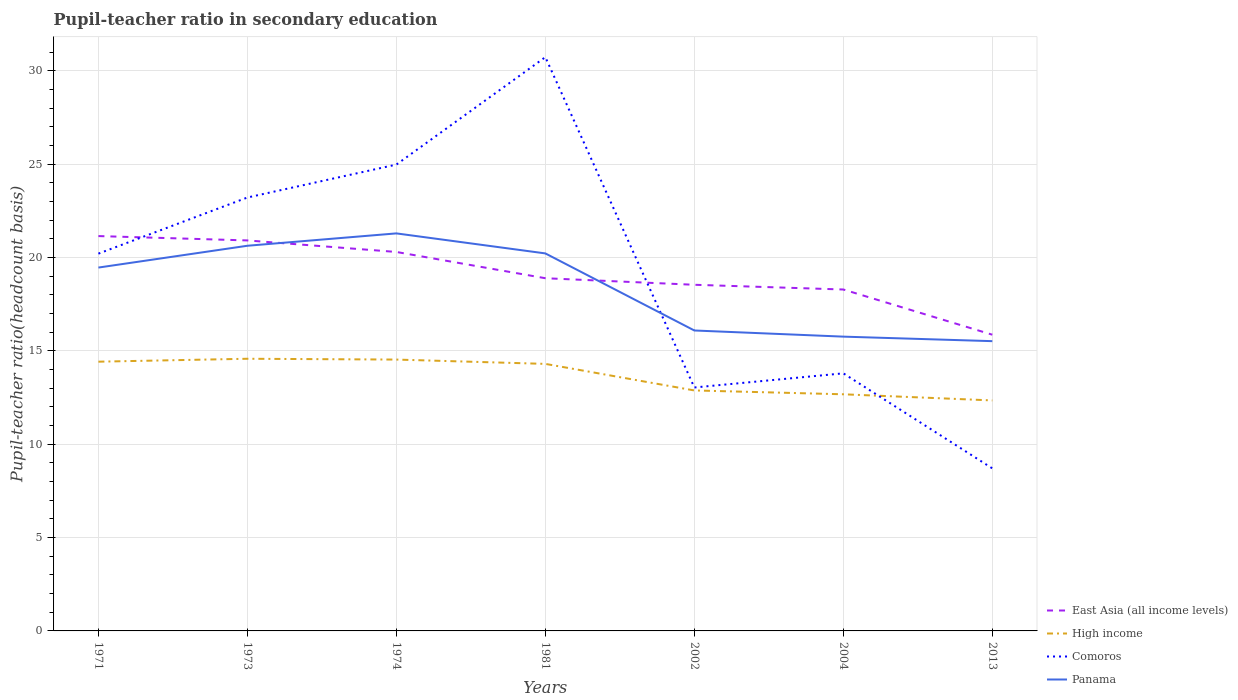How many different coloured lines are there?
Give a very brief answer. 4. Does the line corresponding to East Asia (all income levels) intersect with the line corresponding to Panama?
Make the answer very short. Yes. Across all years, what is the maximum pupil-teacher ratio in secondary education in High income?
Make the answer very short. 12.34. What is the total pupil-teacher ratio in secondary education in High income in the graph?
Offer a very short reply. 1.63. What is the difference between the highest and the second highest pupil-teacher ratio in secondary education in High income?
Provide a succinct answer. 2.23. What is the difference between the highest and the lowest pupil-teacher ratio in secondary education in High income?
Offer a very short reply. 4. What is the difference between two consecutive major ticks on the Y-axis?
Keep it short and to the point. 5. Are the values on the major ticks of Y-axis written in scientific E-notation?
Keep it short and to the point. No. Does the graph contain any zero values?
Offer a very short reply. No. Does the graph contain grids?
Your response must be concise. Yes. How many legend labels are there?
Provide a short and direct response. 4. What is the title of the graph?
Offer a terse response. Pupil-teacher ratio in secondary education. Does "Thailand" appear as one of the legend labels in the graph?
Provide a succinct answer. No. What is the label or title of the X-axis?
Your response must be concise. Years. What is the label or title of the Y-axis?
Keep it short and to the point. Pupil-teacher ratio(headcount basis). What is the Pupil-teacher ratio(headcount basis) of East Asia (all income levels) in 1971?
Offer a terse response. 21.15. What is the Pupil-teacher ratio(headcount basis) in High income in 1971?
Make the answer very short. 14.42. What is the Pupil-teacher ratio(headcount basis) of Comoros in 1971?
Your answer should be compact. 20.21. What is the Pupil-teacher ratio(headcount basis) in Panama in 1971?
Provide a succinct answer. 19.46. What is the Pupil-teacher ratio(headcount basis) of East Asia (all income levels) in 1973?
Ensure brevity in your answer.  20.91. What is the Pupil-teacher ratio(headcount basis) of High income in 1973?
Offer a very short reply. 14.58. What is the Pupil-teacher ratio(headcount basis) in Comoros in 1973?
Give a very brief answer. 23.21. What is the Pupil-teacher ratio(headcount basis) of Panama in 1973?
Your response must be concise. 20.63. What is the Pupil-teacher ratio(headcount basis) in East Asia (all income levels) in 1974?
Ensure brevity in your answer.  20.3. What is the Pupil-teacher ratio(headcount basis) of High income in 1974?
Your answer should be compact. 14.53. What is the Pupil-teacher ratio(headcount basis) in Comoros in 1974?
Offer a terse response. 24.98. What is the Pupil-teacher ratio(headcount basis) in Panama in 1974?
Your response must be concise. 21.29. What is the Pupil-teacher ratio(headcount basis) in East Asia (all income levels) in 1981?
Your response must be concise. 18.89. What is the Pupil-teacher ratio(headcount basis) in High income in 1981?
Keep it short and to the point. 14.3. What is the Pupil-teacher ratio(headcount basis) of Comoros in 1981?
Offer a very short reply. 30.73. What is the Pupil-teacher ratio(headcount basis) in Panama in 1981?
Provide a succinct answer. 20.22. What is the Pupil-teacher ratio(headcount basis) in East Asia (all income levels) in 2002?
Provide a succinct answer. 18.54. What is the Pupil-teacher ratio(headcount basis) of High income in 2002?
Give a very brief answer. 12.88. What is the Pupil-teacher ratio(headcount basis) in Comoros in 2002?
Provide a short and direct response. 13.04. What is the Pupil-teacher ratio(headcount basis) of Panama in 2002?
Your answer should be very brief. 16.09. What is the Pupil-teacher ratio(headcount basis) in East Asia (all income levels) in 2004?
Keep it short and to the point. 18.29. What is the Pupil-teacher ratio(headcount basis) of High income in 2004?
Keep it short and to the point. 12.67. What is the Pupil-teacher ratio(headcount basis) of Comoros in 2004?
Provide a short and direct response. 13.8. What is the Pupil-teacher ratio(headcount basis) of Panama in 2004?
Keep it short and to the point. 15.76. What is the Pupil-teacher ratio(headcount basis) of East Asia (all income levels) in 2013?
Keep it short and to the point. 15.86. What is the Pupil-teacher ratio(headcount basis) of High income in 2013?
Provide a short and direct response. 12.34. What is the Pupil-teacher ratio(headcount basis) in Comoros in 2013?
Ensure brevity in your answer.  8.71. What is the Pupil-teacher ratio(headcount basis) of Panama in 2013?
Make the answer very short. 15.52. Across all years, what is the maximum Pupil-teacher ratio(headcount basis) in East Asia (all income levels)?
Keep it short and to the point. 21.15. Across all years, what is the maximum Pupil-teacher ratio(headcount basis) of High income?
Provide a short and direct response. 14.58. Across all years, what is the maximum Pupil-teacher ratio(headcount basis) of Comoros?
Your answer should be very brief. 30.73. Across all years, what is the maximum Pupil-teacher ratio(headcount basis) of Panama?
Ensure brevity in your answer.  21.29. Across all years, what is the minimum Pupil-teacher ratio(headcount basis) of East Asia (all income levels)?
Your answer should be compact. 15.86. Across all years, what is the minimum Pupil-teacher ratio(headcount basis) in High income?
Offer a very short reply. 12.34. Across all years, what is the minimum Pupil-teacher ratio(headcount basis) in Comoros?
Offer a very short reply. 8.71. Across all years, what is the minimum Pupil-teacher ratio(headcount basis) in Panama?
Your answer should be compact. 15.52. What is the total Pupil-teacher ratio(headcount basis) of East Asia (all income levels) in the graph?
Your answer should be very brief. 133.94. What is the total Pupil-teacher ratio(headcount basis) in High income in the graph?
Provide a short and direct response. 95.73. What is the total Pupil-teacher ratio(headcount basis) of Comoros in the graph?
Provide a short and direct response. 134.67. What is the total Pupil-teacher ratio(headcount basis) of Panama in the graph?
Provide a short and direct response. 128.97. What is the difference between the Pupil-teacher ratio(headcount basis) in East Asia (all income levels) in 1971 and that in 1973?
Your response must be concise. 0.23. What is the difference between the Pupil-teacher ratio(headcount basis) in High income in 1971 and that in 1973?
Provide a short and direct response. -0.16. What is the difference between the Pupil-teacher ratio(headcount basis) of Comoros in 1971 and that in 1973?
Your response must be concise. -3.01. What is the difference between the Pupil-teacher ratio(headcount basis) of Panama in 1971 and that in 1973?
Give a very brief answer. -1.17. What is the difference between the Pupil-teacher ratio(headcount basis) in East Asia (all income levels) in 1971 and that in 1974?
Keep it short and to the point. 0.85. What is the difference between the Pupil-teacher ratio(headcount basis) in High income in 1971 and that in 1974?
Make the answer very short. -0.11. What is the difference between the Pupil-teacher ratio(headcount basis) of Comoros in 1971 and that in 1974?
Keep it short and to the point. -4.77. What is the difference between the Pupil-teacher ratio(headcount basis) of Panama in 1971 and that in 1974?
Offer a terse response. -1.83. What is the difference between the Pupil-teacher ratio(headcount basis) of East Asia (all income levels) in 1971 and that in 1981?
Make the answer very short. 2.26. What is the difference between the Pupil-teacher ratio(headcount basis) in High income in 1971 and that in 1981?
Provide a short and direct response. 0.12. What is the difference between the Pupil-teacher ratio(headcount basis) in Comoros in 1971 and that in 1981?
Your answer should be compact. -10.52. What is the difference between the Pupil-teacher ratio(headcount basis) of Panama in 1971 and that in 1981?
Provide a short and direct response. -0.76. What is the difference between the Pupil-teacher ratio(headcount basis) in East Asia (all income levels) in 1971 and that in 2002?
Your answer should be compact. 2.61. What is the difference between the Pupil-teacher ratio(headcount basis) in High income in 1971 and that in 2002?
Your response must be concise. 1.54. What is the difference between the Pupil-teacher ratio(headcount basis) in Comoros in 1971 and that in 2002?
Your response must be concise. 7.17. What is the difference between the Pupil-teacher ratio(headcount basis) in Panama in 1971 and that in 2002?
Provide a short and direct response. 3.37. What is the difference between the Pupil-teacher ratio(headcount basis) of East Asia (all income levels) in 1971 and that in 2004?
Ensure brevity in your answer.  2.86. What is the difference between the Pupil-teacher ratio(headcount basis) in High income in 1971 and that in 2004?
Give a very brief answer. 1.75. What is the difference between the Pupil-teacher ratio(headcount basis) of Comoros in 1971 and that in 2004?
Offer a very short reply. 6.41. What is the difference between the Pupil-teacher ratio(headcount basis) in Panama in 1971 and that in 2004?
Ensure brevity in your answer.  3.7. What is the difference between the Pupil-teacher ratio(headcount basis) of East Asia (all income levels) in 1971 and that in 2013?
Give a very brief answer. 5.28. What is the difference between the Pupil-teacher ratio(headcount basis) of High income in 1971 and that in 2013?
Your answer should be very brief. 2.08. What is the difference between the Pupil-teacher ratio(headcount basis) of Comoros in 1971 and that in 2013?
Offer a terse response. 11.5. What is the difference between the Pupil-teacher ratio(headcount basis) in Panama in 1971 and that in 2013?
Your answer should be compact. 3.94. What is the difference between the Pupil-teacher ratio(headcount basis) of East Asia (all income levels) in 1973 and that in 1974?
Offer a very short reply. 0.62. What is the difference between the Pupil-teacher ratio(headcount basis) in High income in 1973 and that in 1974?
Keep it short and to the point. 0.04. What is the difference between the Pupil-teacher ratio(headcount basis) of Comoros in 1973 and that in 1974?
Offer a very short reply. -1.76. What is the difference between the Pupil-teacher ratio(headcount basis) of Panama in 1973 and that in 1974?
Give a very brief answer. -0.66. What is the difference between the Pupil-teacher ratio(headcount basis) of East Asia (all income levels) in 1973 and that in 1981?
Provide a short and direct response. 2.02. What is the difference between the Pupil-teacher ratio(headcount basis) in High income in 1973 and that in 1981?
Offer a terse response. 0.27. What is the difference between the Pupil-teacher ratio(headcount basis) in Comoros in 1973 and that in 1981?
Offer a terse response. -7.52. What is the difference between the Pupil-teacher ratio(headcount basis) of Panama in 1973 and that in 1981?
Offer a very short reply. 0.41. What is the difference between the Pupil-teacher ratio(headcount basis) of East Asia (all income levels) in 1973 and that in 2002?
Your answer should be very brief. 2.38. What is the difference between the Pupil-teacher ratio(headcount basis) in High income in 1973 and that in 2002?
Provide a short and direct response. 1.7. What is the difference between the Pupil-teacher ratio(headcount basis) of Comoros in 1973 and that in 2002?
Your response must be concise. 10.17. What is the difference between the Pupil-teacher ratio(headcount basis) of Panama in 1973 and that in 2002?
Offer a very short reply. 4.54. What is the difference between the Pupil-teacher ratio(headcount basis) of East Asia (all income levels) in 1973 and that in 2004?
Give a very brief answer. 2.63. What is the difference between the Pupil-teacher ratio(headcount basis) in High income in 1973 and that in 2004?
Provide a succinct answer. 1.9. What is the difference between the Pupil-teacher ratio(headcount basis) of Comoros in 1973 and that in 2004?
Offer a very short reply. 9.42. What is the difference between the Pupil-teacher ratio(headcount basis) in Panama in 1973 and that in 2004?
Offer a very short reply. 4.87. What is the difference between the Pupil-teacher ratio(headcount basis) in East Asia (all income levels) in 1973 and that in 2013?
Keep it short and to the point. 5.05. What is the difference between the Pupil-teacher ratio(headcount basis) of High income in 1973 and that in 2013?
Give a very brief answer. 2.23. What is the difference between the Pupil-teacher ratio(headcount basis) in Comoros in 1973 and that in 2013?
Provide a succinct answer. 14.51. What is the difference between the Pupil-teacher ratio(headcount basis) in Panama in 1973 and that in 2013?
Offer a terse response. 5.11. What is the difference between the Pupil-teacher ratio(headcount basis) in East Asia (all income levels) in 1974 and that in 1981?
Offer a very short reply. 1.41. What is the difference between the Pupil-teacher ratio(headcount basis) in High income in 1974 and that in 1981?
Offer a terse response. 0.23. What is the difference between the Pupil-teacher ratio(headcount basis) of Comoros in 1974 and that in 1981?
Give a very brief answer. -5.75. What is the difference between the Pupil-teacher ratio(headcount basis) of Panama in 1974 and that in 1981?
Provide a short and direct response. 1.07. What is the difference between the Pupil-teacher ratio(headcount basis) of East Asia (all income levels) in 1974 and that in 2002?
Your answer should be very brief. 1.76. What is the difference between the Pupil-teacher ratio(headcount basis) of High income in 1974 and that in 2002?
Provide a succinct answer. 1.65. What is the difference between the Pupil-teacher ratio(headcount basis) of Comoros in 1974 and that in 2002?
Provide a succinct answer. 11.94. What is the difference between the Pupil-teacher ratio(headcount basis) of Panama in 1974 and that in 2002?
Offer a terse response. 5.2. What is the difference between the Pupil-teacher ratio(headcount basis) in East Asia (all income levels) in 1974 and that in 2004?
Offer a very short reply. 2.01. What is the difference between the Pupil-teacher ratio(headcount basis) of High income in 1974 and that in 2004?
Ensure brevity in your answer.  1.86. What is the difference between the Pupil-teacher ratio(headcount basis) in Comoros in 1974 and that in 2004?
Make the answer very short. 11.18. What is the difference between the Pupil-teacher ratio(headcount basis) of Panama in 1974 and that in 2004?
Offer a very short reply. 5.53. What is the difference between the Pupil-teacher ratio(headcount basis) of East Asia (all income levels) in 1974 and that in 2013?
Your response must be concise. 4.43. What is the difference between the Pupil-teacher ratio(headcount basis) of High income in 1974 and that in 2013?
Give a very brief answer. 2.19. What is the difference between the Pupil-teacher ratio(headcount basis) of Comoros in 1974 and that in 2013?
Provide a short and direct response. 16.27. What is the difference between the Pupil-teacher ratio(headcount basis) of Panama in 1974 and that in 2013?
Provide a short and direct response. 5.77. What is the difference between the Pupil-teacher ratio(headcount basis) of East Asia (all income levels) in 1981 and that in 2002?
Your answer should be compact. 0.35. What is the difference between the Pupil-teacher ratio(headcount basis) of High income in 1981 and that in 2002?
Keep it short and to the point. 1.42. What is the difference between the Pupil-teacher ratio(headcount basis) in Comoros in 1981 and that in 2002?
Your response must be concise. 17.69. What is the difference between the Pupil-teacher ratio(headcount basis) of Panama in 1981 and that in 2002?
Your answer should be very brief. 4.13. What is the difference between the Pupil-teacher ratio(headcount basis) in East Asia (all income levels) in 1981 and that in 2004?
Provide a short and direct response. 0.6. What is the difference between the Pupil-teacher ratio(headcount basis) of High income in 1981 and that in 2004?
Your answer should be compact. 1.63. What is the difference between the Pupil-teacher ratio(headcount basis) of Comoros in 1981 and that in 2004?
Your response must be concise. 16.93. What is the difference between the Pupil-teacher ratio(headcount basis) of Panama in 1981 and that in 2004?
Give a very brief answer. 4.46. What is the difference between the Pupil-teacher ratio(headcount basis) of East Asia (all income levels) in 1981 and that in 2013?
Your answer should be compact. 3.02. What is the difference between the Pupil-teacher ratio(headcount basis) in High income in 1981 and that in 2013?
Your answer should be compact. 1.96. What is the difference between the Pupil-teacher ratio(headcount basis) in Comoros in 1981 and that in 2013?
Give a very brief answer. 22.02. What is the difference between the Pupil-teacher ratio(headcount basis) of Panama in 1981 and that in 2013?
Offer a very short reply. 4.7. What is the difference between the Pupil-teacher ratio(headcount basis) of East Asia (all income levels) in 2002 and that in 2004?
Offer a very short reply. 0.25. What is the difference between the Pupil-teacher ratio(headcount basis) of High income in 2002 and that in 2004?
Give a very brief answer. 0.21. What is the difference between the Pupil-teacher ratio(headcount basis) of Comoros in 2002 and that in 2004?
Your answer should be compact. -0.76. What is the difference between the Pupil-teacher ratio(headcount basis) of Panama in 2002 and that in 2004?
Give a very brief answer. 0.33. What is the difference between the Pupil-teacher ratio(headcount basis) of East Asia (all income levels) in 2002 and that in 2013?
Offer a terse response. 2.67. What is the difference between the Pupil-teacher ratio(headcount basis) in High income in 2002 and that in 2013?
Provide a short and direct response. 0.53. What is the difference between the Pupil-teacher ratio(headcount basis) in Comoros in 2002 and that in 2013?
Give a very brief answer. 4.33. What is the difference between the Pupil-teacher ratio(headcount basis) of Panama in 2002 and that in 2013?
Keep it short and to the point. 0.57. What is the difference between the Pupil-teacher ratio(headcount basis) of East Asia (all income levels) in 2004 and that in 2013?
Provide a short and direct response. 2.42. What is the difference between the Pupil-teacher ratio(headcount basis) of High income in 2004 and that in 2013?
Ensure brevity in your answer.  0.33. What is the difference between the Pupil-teacher ratio(headcount basis) of Comoros in 2004 and that in 2013?
Your answer should be compact. 5.09. What is the difference between the Pupil-teacher ratio(headcount basis) in Panama in 2004 and that in 2013?
Give a very brief answer. 0.24. What is the difference between the Pupil-teacher ratio(headcount basis) in East Asia (all income levels) in 1971 and the Pupil-teacher ratio(headcount basis) in High income in 1973?
Give a very brief answer. 6.57. What is the difference between the Pupil-teacher ratio(headcount basis) of East Asia (all income levels) in 1971 and the Pupil-teacher ratio(headcount basis) of Comoros in 1973?
Offer a very short reply. -2.07. What is the difference between the Pupil-teacher ratio(headcount basis) of East Asia (all income levels) in 1971 and the Pupil-teacher ratio(headcount basis) of Panama in 1973?
Make the answer very short. 0.52. What is the difference between the Pupil-teacher ratio(headcount basis) of High income in 1971 and the Pupil-teacher ratio(headcount basis) of Comoros in 1973?
Provide a succinct answer. -8.79. What is the difference between the Pupil-teacher ratio(headcount basis) in High income in 1971 and the Pupil-teacher ratio(headcount basis) in Panama in 1973?
Provide a short and direct response. -6.21. What is the difference between the Pupil-teacher ratio(headcount basis) of Comoros in 1971 and the Pupil-teacher ratio(headcount basis) of Panama in 1973?
Ensure brevity in your answer.  -0.42. What is the difference between the Pupil-teacher ratio(headcount basis) of East Asia (all income levels) in 1971 and the Pupil-teacher ratio(headcount basis) of High income in 1974?
Keep it short and to the point. 6.61. What is the difference between the Pupil-teacher ratio(headcount basis) in East Asia (all income levels) in 1971 and the Pupil-teacher ratio(headcount basis) in Comoros in 1974?
Your answer should be very brief. -3.83. What is the difference between the Pupil-teacher ratio(headcount basis) in East Asia (all income levels) in 1971 and the Pupil-teacher ratio(headcount basis) in Panama in 1974?
Your response must be concise. -0.14. What is the difference between the Pupil-teacher ratio(headcount basis) in High income in 1971 and the Pupil-teacher ratio(headcount basis) in Comoros in 1974?
Keep it short and to the point. -10.56. What is the difference between the Pupil-teacher ratio(headcount basis) of High income in 1971 and the Pupil-teacher ratio(headcount basis) of Panama in 1974?
Give a very brief answer. -6.87. What is the difference between the Pupil-teacher ratio(headcount basis) of Comoros in 1971 and the Pupil-teacher ratio(headcount basis) of Panama in 1974?
Your answer should be compact. -1.08. What is the difference between the Pupil-teacher ratio(headcount basis) of East Asia (all income levels) in 1971 and the Pupil-teacher ratio(headcount basis) of High income in 1981?
Offer a terse response. 6.85. What is the difference between the Pupil-teacher ratio(headcount basis) of East Asia (all income levels) in 1971 and the Pupil-teacher ratio(headcount basis) of Comoros in 1981?
Offer a terse response. -9.58. What is the difference between the Pupil-teacher ratio(headcount basis) of East Asia (all income levels) in 1971 and the Pupil-teacher ratio(headcount basis) of Panama in 1981?
Your answer should be very brief. 0.93. What is the difference between the Pupil-teacher ratio(headcount basis) of High income in 1971 and the Pupil-teacher ratio(headcount basis) of Comoros in 1981?
Your answer should be compact. -16.31. What is the difference between the Pupil-teacher ratio(headcount basis) in High income in 1971 and the Pupil-teacher ratio(headcount basis) in Panama in 1981?
Your answer should be compact. -5.8. What is the difference between the Pupil-teacher ratio(headcount basis) in Comoros in 1971 and the Pupil-teacher ratio(headcount basis) in Panama in 1981?
Provide a succinct answer. -0.01. What is the difference between the Pupil-teacher ratio(headcount basis) of East Asia (all income levels) in 1971 and the Pupil-teacher ratio(headcount basis) of High income in 2002?
Your answer should be compact. 8.27. What is the difference between the Pupil-teacher ratio(headcount basis) of East Asia (all income levels) in 1971 and the Pupil-teacher ratio(headcount basis) of Comoros in 2002?
Offer a terse response. 8.11. What is the difference between the Pupil-teacher ratio(headcount basis) in East Asia (all income levels) in 1971 and the Pupil-teacher ratio(headcount basis) in Panama in 2002?
Your answer should be compact. 5.06. What is the difference between the Pupil-teacher ratio(headcount basis) of High income in 1971 and the Pupil-teacher ratio(headcount basis) of Comoros in 2002?
Provide a short and direct response. 1.38. What is the difference between the Pupil-teacher ratio(headcount basis) of High income in 1971 and the Pupil-teacher ratio(headcount basis) of Panama in 2002?
Your answer should be very brief. -1.67. What is the difference between the Pupil-teacher ratio(headcount basis) in Comoros in 1971 and the Pupil-teacher ratio(headcount basis) in Panama in 2002?
Your response must be concise. 4.12. What is the difference between the Pupil-teacher ratio(headcount basis) of East Asia (all income levels) in 1971 and the Pupil-teacher ratio(headcount basis) of High income in 2004?
Provide a short and direct response. 8.47. What is the difference between the Pupil-teacher ratio(headcount basis) of East Asia (all income levels) in 1971 and the Pupil-teacher ratio(headcount basis) of Comoros in 2004?
Give a very brief answer. 7.35. What is the difference between the Pupil-teacher ratio(headcount basis) of East Asia (all income levels) in 1971 and the Pupil-teacher ratio(headcount basis) of Panama in 2004?
Provide a succinct answer. 5.39. What is the difference between the Pupil-teacher ratio(headcount basis) of High income in 1971 and the Pupil-teacher ratio(headcount basis) of Comoros in 2004?
Keep it short and to the point. 0.62. What is the difference between the Pupil-teacher ratio(headcount basis) of High income in 1971 and the Pupil-teacher ratio(headcount basis) of Panama in 2004?
Keep it short and to the point. -1.34. What is the difference between the Pupil-teacher ratio(headcount basis) of Comoros in 1971 and the Pupil-teacher ratio(headcount basis) of Panama in 2004?
Keep it short and to the point. 4.45. What is the difference between the Pupil-teacher ratio(headcount basis) of East Asia (all income levels) in 1971 and the Pupil-teacher ratio(headcount basis) of High income in 2013?
Ensure brevity in your answer.  8.8. What is the difference between the Pupil-teacher ratio(headcount basis) in East Asia (all income levels) in 1971 and the Pupil-teacher ratio(headcount basis) in Comoros in 2013?
Make the answer very short. 12.44. What is the difference between the Pupil-teacher ratio(headcount basis) of East Asia (all income levels) in 1971 and the Pupil-teacher ratio(headcount basis) of Panama in 2013?
Your response must be concise. 5.63. What is the difference between the Pupil-teacher ratio(headcount basis) of High income in 1971 and the Pupil-teacher ratio(headcount basis) of Comoros in 2013?
Offer a terse response. 5.71. What is the difference between the Pupil-teacher ratio(headcount basis) in High income in 1971 and the Pupil-teacher ratio(headcount basis) in Panama in 2013?
Offer a very short reply. -1.1. What is the difference between the Pupil-teacher ratio(headcount basis) of Comoros in 1971 and the Pupil-teacher ratio(headcount basis) of Panama in 2013?
Make the answer very short. 4.69. What is the difference between the Pupil-teacher ratio(headcount basis) of East Asia (all income levels) in 1973 and the Pupil-teacher ratio(headcount basis) of High income in 1974?
Ensure brevity in your answer.  6.38. What is the difference between the Pupil-teacher ratio(headcount basis) of East Asia (all income levels) in 1973 and the Pupil-teacher ratio(headcount basis) of Comoros in 1974?
Give a very brief answer. -4.06. What is the difference between the Pupil-teacher ratio(headcount basis) of East Asia (all income levels) in 1973 and the Pupil-teacher ratio(headcount basis) of Panama in 1974?
Give a very brief answer. -0.38. What is the difference between the Pupil-teacher ratio(headcount basis) in High income in 1973 and the Pupil-teacher ratio(headcount basis) in Panama in 1974?
Provide a succinct answer. -6.71. What is the difference between the Pupil-teacher ratio(headcount basis) of Comoros in 1973 and the Pupil-teacher ratio(headcount basis) of Panama in 1974?
Your answer should be compact. 1.92. What is the difference between the Pupil-teacher ratio(headcount basis) of East Asia (all income levels) in 1973 and the Pupil-teacher ratio(headcount basis) of High income in 1981?
Ensure brevity in your answer.  6.61. What is the difference between the Pupil-teacher ratio(headcount basis) in East Asia (all income levels) in 1973 and the Pupil-teacher ratio(headcount basis) in Comoros in 1981?
Make the answer very short. -9.82. What is the difference between the Pupil-teacher ratio(headcount basis) of East Asia (all income levels) in 1973 and the Pupil-teacher ratio(headcount basis) of Panama in 1981?
Your answer should be very brief. 0.7. What is the difference between the Pupil-teacher ratio(headcount basis) of High income in 1973 and the Pupil-teacher ratio(headcount basis) of Comoros in 1981?
Your response must be concise. -16.15. What is the difference between the Pupil-teacher ratio(headcount basis) in High income in 1973 and the Pupil-teacher ratio(headcount basis) in Panama in 1981?
Your answer should be compact. -5.64. What is the difference between the Pupil-teacher ratio(headcount basis) of Comoros in 1973 and the Pupil-teacher ratio(headcount basis) of Panama in 1981?
Give a very brief answer. 2.99. What is the difference between the Pupil-teacher ratio(headcount basis) in East Asia (all income levels) in 1973 and the Pupil-teacher ratio(headcount basis) in High income in 2002?
Offer a very short reply. 8.03. What is the difference between the Pupil-teacher ratio(headcount basis) in East Asia (all income levels) in 1973 and the Pupil-teacher ratio(headcount basis) in Comoros in 2002?
Offer a terse response. 7.88. What is the difference between the Pupil-teacher ratio(headcount basis) in East Asia (all income levels) in 1973 and the Pupil-teacher ratio(headcount basis) in Panama in 2002?
Give a very brief answer. 4.82. What is the difference between the Pupil-teacher ratio(headcount basis) of High income in 1973 and the Pupil-teacher ratio(headcount basis) of Comoros in 2002?
Provide a succinct answer. 1.54. What is the difference between the Pupil-teacher ratio(headcount basis) of High income in 1973 and the Pupil-teacher ratio(headcount basis) of Panama in 2002?
Provide a short and direct response. -1.51. What is the difference between the Pupil-teacher ratio(headcount basis) of Comoros in 1973 and the Pupil-teacher ratio(headcount basis) of Panama in 2002?
Keep it short and to the point. 7.12. What is the difference between the Pupil-teacher ratio(headcount basis) in East Asia (all income levels) in 1973 and the Pupil-teacher ratio(headcount basis) in High income in 2004?
Provide a succinct answer. 8.24. What is the difference between the Pupil-teacher ratio(headcount basis) of East Asia (all income levels) in 1973 and the Pupil-teacher ratio(headcount basis) of Comoros in 2004?
Keep it short and to the point. 7.12. What is the difference between the Pupil-teacher ratio(headcount basis) in East Asia (all income levels) in 1973 and the Pupil-teacher ratio(headcount basis) in Panama in 2004?
Your answer should be compact. 5.15. What is the difference between the Pupil-teacher ratio(headcount basis) in High income in 1973 and the Pupil-teacher ratio(headcount basis) in Comoros in 2004?
Provide a short and direct response. 0.78. What is the difference between the Pupil-teacher ratio(headcount basis) in High income in 1973 and the Pupil-teacher ratio(headcount basis) in Panama in 2004?
Offer a very short reply. -1.18. What is the difference between the Pupil-teacher ratio(headcount basis) of Comoros in 1973 and the Pupil-teacher ratio(headcount basis) of Panama in 2004?
Offer a very short reply. 7.45. What is the difference between the Pupil-teacher ratio(headcount basis) in East Asia (all income levels) in 1973 and the Pupil-teacher ratio(headcount basis) in High income in 2013?
Offer a very short reply. 8.57. What is the difference between the Pupil-teacher ratio(headcount basis) of East Asia (all income levels) in 1973 and the Pupil-teacher ratio(headcount basis) of Comoros in 2013?
Your response must be concise. 12.21. What is the difference between the Pupil-teacher ratio(headcount basis) of East Asia (all income levels) in 1973 and the Pupil-teacher ratio(headcount basis) of Panama in 2013?
Your response must be concise. 5.4. What is the difference between the Pupil-teacher ratio(headcount basis) of High income in 1973 and the Pupil-teacher ratio(headcount basis) of Comoros in 2013?
Offer a terse response. 5.87. What is the difference between the Pupil-teacher ratio(headcount basis) of High income in 1973 and the Pupil-teacher ratio(headcount basis) of Panama in 2013?
Provide a short and direct response. -0.94. What is the difference between the Pupil-teacher ratio(headcount basis) of Comoros in 1973 and the Pupil-teacher ratio(headcount basis) of Panama in 2013?
Ensure brevity in your answer.  7.69. What is the difference between the Pupil-teacher ratio(headcount basis) in East Asia (all income levels) in 1974 and the Pupil-teacher ratio(headcount basis) in High income in 1981?
Your answer should be very brief. 5.99. What is the difference between the Pupil-teacher ratio(headcount basis) of East Asia (all income levels) in 1974 and the Pupil-teacher ratio(headcount basis) of Comoros in 1981?
Give a very brief answer. -10.43. What is the difference between the Pupil-teacher ratio(headcount basis) of East Asia (all income levels) in 1974 and the Pupil-teacher ratio(headcount basis) of Panama in 1981?
Your answer should be very brief. 0.08. What is the difference between the Pupil-teacher ratio(headcount basis) of High income in 1974 and the Pupil-teacher ratio(headcount basis) of Comoros in 1981?
Provide a succinct answer. -16.2. What is the difference between the Pupil-teacher ratio(headcount basis) in High income in 1974 and the Pupil-teacher ratio(headcount basis) in Panama in 1981?
Make the answer very short. -5.69. What is the difference between the Pupil-teacher ratio(headcount basis) in Comoros in 1974 and the Pupil-teacher ratio(headcount basis) in Panama in 1981?
Your answer should be very brief. 4.76. What is the difference between the Pupil-teacher ratio(headcount basis) in East Asia (all income levels) in 1974 and the Pupil-teacher ratio(headcount basis) in High income in 2002?
Give a very brief answer. 7.42. What is the difference between the Pupil-teacher ratio(headcount basis) of East Asia (all income levels) in 1974 and the Pupil-teacher ratio(headcount basis) of Comoros in 2002?
Provide a succinct answer. 7.26. What is the difference between the Pupil-teacher ratio(headcount basis) of East Asia (all income levels) in 1974 and the Pupil-teacher ratio(headcount basis) of Panama in 2002?
Give a very brief answer. 4.21. What is the difference between the Pupil-teacher ratio(headcount basis) in High income in 1974 and the Pupil-teacher ratio(headcount basis) in Comoros in 2002?
Your answer should be very brief. 1.49. What is the difference between the Pupil-teacher ratio(headcount basis) in High income in 1974 and the Pupil-teacher ratio(headcount basis) in Panama in 2002?
Your response must be concise. -1.56. What is the difference between the Pupil-teacher ratio(headcount basis) of Comoros in 1974 and the Pupil-teacher ratio(headcount basis) of Panama in 2002?
Your response must be concise. 8.89. What is the difference between the Pupil-teacher ratio(headcount basis) of East Asia (all income levels) in 1974 and the Pupil-teacher ratio(headcount basis) of High income in 2004?
Your answer should be very brief. 7.62. What is the difference between the Pupil-teacher ratio(headcount basis) in East Asia (all income levels) in 1974 and the Pupil-teacher ratio(headcount basis) in Comoros in 2004?
Your answer should be compact. 6.5. What is the difference between the Pupil-teacher ratio(headcount basis) in East Asia (all income levels) in 1974 and the Pupil-teacher ratio(headcount basis) in Panama in 2004?
Make the answer very short. 4.53. What is the difference between the Pupil-teacher ratio(headcount basis) of High income in 1974 and the Pupil-teacher ratio(headcount basis) of Comoros in 2004?
Your answer should be compact. 0.74. What is the difference between the Pupil-teacher ratio(headcount basis) in High income in 1974 and the Pupil-teacher ratio(headcount basis) in Panama in 2004?
Your answer should be compact. -1.23. What is the difference between the Pupil-teacher ratio(headcount basis) in Comoros in 1974 and the Pupil-teacher ratio(headcount basis) in Panama in 2004?
Give a very brief answer. 9.22. What is the difference between the Pupil-teacher ratio(headcount basis) of East Asia (all income levels) in 1974 and the Pupil-teacher ratio(headcount basis) of High income in 2013?
Provide a short and direct response. 7.95. What is the difference between the Pupil-teacher ratio(headcount basis) of East Asia (all income levels) in 1974 and the Pupil-teacher ratio(headcount basis) of Comoros in 2013?
Provide a short and direct response. 11.59. What is the difference between the Pupil-teacher ratio(headcount basis) in East Asia (all income levels) in 1974 and the Pupil-teacher ratio(headcount basis) in Panama in 2013?
Your answer should be very brief. 4.78. What is the difference between the Pupil-teacher ratio(headcount basis) in High income in 1974 and the Pupil-teacher ratio(headcount basis) in Comoros in 2013?
Provide a short and direct response. 5.83. What is the difference between the Pupil-teacher ratio(headcount basis) of High income in 1974 and the Pupil-teacher ratio(headcount basis) of Panama in 2013?
Ensure brevity in your answer.  -0.99. What is the difference between the Pupil-teacher ratio(headcount basis) in Comoros in 1974 and the Pupil-teacher ratio(headcount basis) in Panama in 2013?
Make the answer very short. 9.46. What is the difference between the Pupil-teacher ratio(headcount basis) of East Asia (all income levels) in 1981 and the Pupil-teacher ratio(headcount basis) of High income in 2002?
Give a very brief answer. 6.01. What is the difference between the Pupil-teacher ratio(headcount basis) in East Asia (all income levels) in 1981 and the Pupil-teacher ratio(headcount basis) in Comoros in 2002?
Make the answer very short. 5.85. What is the difference between the Pupil-teacher ratio(headcount basis) in East Asia (all income levels) in 1981 and the Pupil-teacher ratio(headcount basis) in Panama in 2002?
Offer a terse response. 2.8. What is the difference between the Pupil-teacher ratio(headcount basis) in High income in 1981 and the Pupil-teacher ratio(headcount basis) in Comoros in 2002?
Provide a short and direct response. 1.26. What is the difference between the Pupil-teacher ratio(headcount basis) of High income in 1981 and the Pupil-teacher ratio(headcount basis) of Panama in 2002?
Offer a very short reply. -1.79. What is the difference between the Pupil-teacher ratio(headcount basis) of Comoros in 1981 and the Pupil-teacher ratio(headcount basis) of Panama in 2002?
Give a very brief answer. 14.64. What is the difference between the Pupil-teacher ratio(headcount basis) of East Asia (all income levels) in 1981 and the Pupil-teacher ratio(headcount basis) of High income in 2004?
Your answer should be very brief. 6.22. What is the difference between the Pupil-teacher ratio(headcount basis) in East Asia (all income levels) in 1981 and the Pupil-teacher ratio(headcount basis) in Comoros in 2004?
Offer a terse response. 5.09. What is the difference between the Pupil-teacher ratio(headcount basis) in East Asia (all income levels) in 1981 and the Pupil-teacher ratio(headcount basis) in Panama in 2004?
Keep it short and to the point. 3.13. What is the difference between the Pupil-teacher ratio(headcount basis) of High income in 1981 and the Pupil-teacher ratio(headcount basis) of Comoros in 2004?
Offer a very short reply. 0.51. What is the difference between the Pupil-teacher ratio(headcount basis) in High income in 1981 and the Pupil-teacher ratio(headcount basis) in Panama in 2004?
Provide a short and direct response. -1.46. What is the difference between the Pupil-teacher ratio(headcount basis) of Comoros in 1981 and the Pupil-teacher ratio(headcount basis) of Panama in 2004?
Offer a terse response. 14.97. What is the difference between the Pupil-teacher ratio(headcount basis) in East Asia (all income levels) in 1981 and the Pupil-teacher ratio(headcount basis) in High income in 2013?
Offer a terse response. 6.54. What is the difference between the Pupil-teacher ratio(headcount basis) in East Asia (all income levels) in 1981 and the Pupil-teacher ratio(headcount basis) in Comoros in 2013?
Your answer should be compact. 10.18. What is the difference between the Pupil-teacher ratio(headcount basis) in East Asia (all income levels) in 1981 and the Pupil-teacher ratio(headcount basis) in Panama in 2013?
Your answer should be very brief. 3.37. What is the difference between the Pupil-teacher ratio(headcount basis) in High income in 1981 and the Pupil-teacher ratio(headcount basis) in Comoros in 2013?
Provide a succinct answer. 5.6. What is the difference between the Pupil-teacher ratio(headcount basis) of High income in 1981 and the Pupil-teacher ratio(headcount basis) of Panama in 2013?
Your response must be concise. -1.22. What is the difference between the Pupil-teacher ratio(headcount basis) of Comoros in 1981 and the Pupil-teacher ratio(headcount basis) of Panama in 2013?
Offer a very short reply. 15.21. What is the difference between the Pupil-teacher ratio(headcount basis) of East Asia (all income levels) in 2002 and the Pupil-teacher ratio(headcount basis) of High income in 2004?
Provide a short and direct response. 5.87. What is the difference between the Pupil-teacher ratio(headcount basis) of East Asia (all income levels) in 2002 and the Pupil-teacher ratio(headcount basis) of Comoros in 2004?
Provide a short and direct response. 4.74. What is the difference between the Pupil-teacher ratio(headcount basis) of East Asia (all income levels) in 2002 and the Pupil-teacher ratio(headcount basis) of Panama in 2004?
Provide a short and direct response. 2.78. What is the difference between the Pupil-teacher ratio(headcount basis) of High income in 2002 and the Pupil-teacher ratio(headcount basis) of Comoros in 2004?
Offer a terse response. -0.92. What is the difference between the Pupil-teacher ratio(headcount basis) of High income in 2002 and the Pupil-teacher ratio(headcount basis) of Panama in 2004?
Provide a succinct answer. -2.88. What is the difference between the Pupil-teacher ratio(headcount basis) in Comoros in 2002 and the Pupil-teacher ratio(headcount basis) in Panama in 2004?
Offer a terse response. -2.72. What is the difference between the Pupil-teacher ratio(headcount basis) in East Asia (all income levels) in 2002 and the Pupil-teacher ratio(headcount basis) in High income in 2013?
Your response must be concise. 6.19. What is the difference between the Pupil-teacher ratio(headcount basis) of East Asia (all income levels) in 2002 and the Pupil-teacher ratio(headcount basis) of Comoros in 2013?
Offer a very short reply. 9.83. What is the difference between the Pupil-teacher ratio(headcount basis) of East Asia (all income levels) in 2002 and the Pupil-teacher ratio(headcount basis) of Panama in 2013?
Offer a terse response. 3.02. What is the difference between the Pupil-teacher ratio(headcount basis) in High income in 2002 and the Pupil-teacher ratio(headcount basis) in Comoros in 2013?
Keep it short and to the point. 4.17. What is the difference between the Pupil-teacher ratio(headcount basis) in High income in 2002 and the Pupil-teacher ratio(headcount basis) in Panama in 2013?
Ensure brevity in your answer.  -2.64. What is the difference between the Pupil-teacher ratio(headcount basis) of Comoros in 2002 and the Pupil-teacher ratio(headcount basis) of Panama in 2013?
Make the answer very short. -2.48. What is the difference between the Pupil-teacher ratio(headcount basis) of East Asia (all income levels) in 2004 and the Pupil-teacher ratio(headcount basis) of High income in 2013?
Your answer should be compact. 5.94. What is the difference between the Pupil-teacher ratio(headcount basis) in East Asia (all income levels) in 2004 and the Pupil-teacher ratio(headcount basis) in Comoros in 2013?
Provide a short and direct response. 9.58. What is the difference between the Pupil-teacher ratio(headcount basis) in East Asia (all income levels) in 2004 and the Pupil-teacher ratio(headcount basis) in Panama in 2013?
Ensure brevity in your answer.  2.77. What is the difference between the Pupil-teacher ratio(headcount basis) in High income in 2004 and the Pupil-teacher ratio(headcount basis) in Comoros in 2013?
Ensure brevity in your answer.  3.97. What is the difference between the Pupil-teacher ratio(headcount basis) of High income in 2004 and the Pupil-teacher ratio(headcount basis) of Panama in 2013?
Your answer should be compact. -2.85. What is the difference between the Pupil-teacher ratio(headcount basis) of Comoros in 2004 and the Pupil-teacher ratio(headcount basis) of Panama in 2013?
Provide a short and direct response. -1.72. What is the average Pupil-teacher ratio(headcount basis) in East Asia (all income levels) per year?
Provide a short and direct response. 19.13. What is the average Pupil-teacher ratio(headcount basis) of High income per year?
Make the answer very short. 13.68. What is the average Pupil-teacher ratio(headcount basis) of Comoros per year?
Keep it short and to the point. 19.24. What is the average Pupil-teacher ratio(headcount basis) in Panama per year?
Your answer should be very brief. 18.42. In the year 1971, what is the difference between the Pupil-teacher ratio(headcount basis) in East Asia (all income levels) and Pupil-teacher ratio(headcount basis) in High income?
Ensure brevity in your answer.  6.73. In the year 1971, what is the difference between the Pupil-teacher ratio(headcount basis) in East Asia (all income levels) and Pupil-teacher ratio(headcount basis) in Comoros?
Offer a very short reply. 0.94. In the year 1971, what is the difference between the Pupil-teacher ratio(headcount basis) in East Asia (all income levels) and Pupil-teacher ratio(headcount basis) in Panama?
Offer a very short reply. 1.69. In the year 1971, what is the difference between the Pupil-teacher ratio(headcount basis) of High income and Pupil-teacher ratio(headcount basis) of Comoros?
Provide a short and direct response. -5.79. In the year 1971, what is the difference between the Pupil-teacher ratio(headcount basis) in High income and Pupil-teacher ratio(headcount basis) in Panama?
Make the answer very short. -5.04. In the year 1971, what is the difference between the Pupil-teacher ratio(headcount basis) in Comoros and Pupil-teacher ratio(headcount basis) in Panama?
Ensure brevity in your answer.  0.75. In the year 1973, what is the difference between the Pupil-teacher ratio(headcount basis) in East Asia (all income levels) and Pupil-teacher ratio(headcount basis) in High income?
Offer a very short reply. 6.34. In the year 1973, what is the difference between the Pupil-teacher ratio(headcount basis) in East Asia (all income levels) and Pupil-teacher ratio(headcount basis) in Comoros?
Keep it short and to the point. -2.3. In the year 1973, what is the difference between the Pupil-teacher ratio(headcount basis) of East Asia (all income levels) and Pupil-teacher ratio(headcount basis) of Panama?
Give a very brief answer. 0.29. In the year 1973, what is the difference between the Pupil-teacher ratio(headcount basis) of High income and Pupil-teacher ratio(headcount basis) of Comoros?
Make the answer very short. -8.64. In the year 1973, what is the difference between the Pupil-teacher ratio(headcount basis) of High income and Pupil-teacher ratio(headcount basis) of Panama?
Provide a succinct answer. -6.05. In the year 1973, what is the difference between the Pupil-teacher ratio(headcount basis) of Comoros and Pupil-teacher ratio(headcount basis) of Panama?
Your answer should be compact. 2.58. In the year 1974, what is the difference between the Pupil-teacher ratio(headcount basis) of East Asia (all income levels) and Pupil-teacher ratio(headcount basis) of High income?
Offer a very short reply. 5.76. In the year 1974, what is the difference between the Pupil-teacher ratio(headcount basis) of East Asia (all income levels) and Pupil-teacher ratio(headcount basis) of Comoros?
Keep it short and to the point. -4.68. In the year 1974, what is the difference between the Pupil-teacher ratio(headcount basis) of East Asia (all income levels) and Pupil-teacher ratio(headcount basis) of Panama?
Your response must be concise. -0.99. In the year 1974, what is the difference between the Pupil-teacher ratio(headcount basis) in High income and Pupil-teacher ratio(headcount basis) in Comoros?
Your answer should be very brief. -10.44. In the year 1974, what is the difference between the Pupil-teacher ratio(headcount basis) of High income and Pupil-teacher ratio(headcount basis) of Panama?
Keep it short and to the point. -6.76. In the year 1974, what is the difference between the Pupil-teacher ratio(headcount basis) of Comoros and Pupil-teacher ratio(headcount basis) of Panama?
Offer a very short reply. 3.69. In the year 1981, what is the difference between the Pupil-teacher ratio(headcount basis) in East Asia (all income levels) and Pupil-teacher ratio(headcount basis) in High income?
Offer a very short reply. 4.59. In the year 1981, what is the difference between the Pupil-teacher ratio(headcount basis) in East Asia (all income levels) and Pupil-teacher ratio(headcount basis) in Comoros?
Keep it short and to the point. -11.84. In the year 1981, what is the difference between the Pupil-teacher ratio(headcount basis) in East Asia (all income levels) and Pupil-teacher ratio(headcount basis) in Panama?
Provide a short and direct response. -1.33. In the year 1981, what is the difference between the Pupil-teacher ratio(headcount basis) in High income and Pupil-teacher ratio(headcount basis) in Comoros?
Make the answer very short. -16.43. In the year 1981, what is the difference between the Pupil-teacher ratio(headcount basis) of High income and Pupil-teacher ratio(headcount basis) of Panama?
Provide a succinct answer. -5.92. In the year 1981, what is the difference between the Pupil-teacher ratio(headcount basis) of Comoros and Pupil-teacher ratio(headcount basis) of Panama?
Your response must be concise. 10.51. In the year 2002, what is the difference between the Pupil-teacher ratio(headcount basis) of East Asia (all income levels) and Pupil-teacher ratio(headcount basis) of High income?
Provide a short and direct response. 5.66. In the year 2002, what is the difference between the Pupil-teacher ratio(headcount basis) of East Asia (all income levels) and Pupil-teacher ratio(headcount basis) of Comoros?
Give a very brief answer. 5.5. In the year 2002, what is the difference between the Pupil-teacher ratio(headcount basis) in East Asia (all income levels) and Pupil-teacher ratio(headcount basis) in Panama?
Make the answer very short. 2.45. In the year 2002, what is the difference between the Pupil-teacher ratio(headcount basis) in High income and Pupil-teacher ratio(headcount basis) in Comoros?
Your response must be concise. -0.16. In the year 2002, what is the difference between the Pupil-teacher ratio(headcount basis) in High income and Pupil-teacher ratio(headcount basis) in Panama?
Your response must be concise. -3.21. In the year 2002, what is the difference between the Pupil-teacher ratio(headcount basis) in Comoros and Pupil-teacher ratio(headcount basis) in Panama?
Offer a terse response. -3.05. In the year 2004, what is the difference between the Pupil-teacher ratio(headcount basis) of East Asia (all income levels) and Pupil-teacher ratio(headcount basis) of High income?
Provide a short and direct response. 5.61. In the year 2004, what is the difference between the Pupil-teacher ratio(headcount basis) in East Asia (all income levels) and Pupil-teacher ratio(headcount basis) in Comoros?
Your answer should be compact. 4.49. In the year 2004, what is the difference between the Pupil-teacher ratio(headcount basis) in East Asia (all income levels) and Pupil-teacher ratio(headcount basis) in Panama?
Make the answer very short. 2.52. In the year 2004, what is the difference between the Pupil-teacher ratio(headcount basis) of High income and Pupil-teacher ratio(headcount basis) of Comoros?
Your response must be concise. -1.12. In the year 2004, what is the difference between the Pupil-teacher ratio(headcount basis) in High income and Pupil-teacher ratio(headcount basis) in Panama?
Keep it short and to the point. -3.09. In the year 2004, what is the difference between the Pupil-teacher ratio(headcount basis) of Comoros and Pupil-teacher ratio(headcount basis) of Panama?
Your response must be concise. -1.97. In the year 2013, what is the difference between the Pupil-teacher ratio(headcount basis) of East Asia (all income levels) and Pupil-teacher ratio(headcount basis) of High income?
Your response must be concise. 3.52. In the year 2013, what is the difference between the Pupil-teacher ratio(headcount basis) of East Asia (all income levels) and Pupil-teacher ratio(headcount basis) of Comoros?
Offer a terse response. 7.16. In the year 2013, what is the difference between the Pupil-teacher ratio(headcount basis) in East Asia (all income levels) and Pupil-teacher ratio(headcount basis) in Panama?
Ensure brevity in your answer.  0.35. In the year 2013, what is the difference between the Pupil-teacher ratio(headcount basis) of High income and Pupil-teacher ratio(headcount basis) of Comoros?
Your answer should be compact. 3.64. In the year 2013, what is the difference between the Pupil-teacher ratio(headcount basis) in High income and Pupil-teacher ratio(headcount basis) in Panama?
Your answer should be very brief. -3.17. In the year 2013, what is the difference between the Pupil-teacher ratio(headcount basis) of Comoros and Pupil-teacher ratio(headcount basis) of Panama?
Ensure brevity in your answer.  -6.81. What is the ratio of the Pupil-teacher ratio(headcount basis) of East Asia (all income levels) in 1971 to that in 1973?
Provide a short and direct response. 1.01. What is the ratio of the Pupil-teacher ratio(headcount basis) in High income in 1971 to that in 1973?
Make the answer very short. 0.99. What is the ratio of the Pupil-teacher ratio(headcount basis) in Comoros in 1971 to that in 1973?
Your response must be concise. 0.87. What is the ratio of the Pupil-teacher ratio(headcount basis) of Panama in 1971 to that in 1973?
Give a very brief answer. 0.94. What is the ratio of the Pupil-teacher ratio(headcount basis) in East Asia (all income levels) in 1971 to that in 1974?
Your response must be concise. 1.04. What is the ratio of the Pupil-teacher ratio(headcount basis) in Comoros in 1971 to that in 1974?
Ensure brevity in your answer.  0.81. What is the ratio of the Pupil-teacher ratio(headcount basis) of Panama in 1971 to that in 1974?
Keep it short and to the point. 0.91. What is the ratio of the Pupil-teacher ratio(headcount basis) of East Asia (all income levels) in 1971 to that in 1981?
Your response must be concise. 1.12. What is the ratio of the Pupil-teacher ratio(headcount basis) in High income in 1971 to that in 1981?
Make the answer very short. 1.01. What is the ratio of the Pupil-teacher ratio(headcount basis) of Comoros in 1971 to that in 1981?
Your response must be concise. 0.66. What is the ratio of the Pupil-teacher ratio(headcount basis) in Panama in 1971 to that in 1981?
Ensure brevity in your answer.  0.96. What is the ratio of the Pupil-teacher ratio(headcount basis) of East Asia (all income levels) in 1971 to that in 2002?
Your answer should be very brief. 1.14. What is the ratio of the Pupil-teacher ratio(headcount basis) of High income in 1971 to that in 2002?
Give a very brief answer. 1.12. What is the ratio of the Pupil-teacher ratio(headcount basis) in Comoros in 1971 to that in 2002?
Offer a very short reply. 1.55. What is the ratio of the Pupil-teacher ratio(headcount basis) in Panama in 1971 to that in 2002?
Keep it short and to the point. 1.21. What is the ratio of the Pupil-teacher ratio(headcount basis) of East Asia (all income levels) in 1971 to that in 2004?
Your response must be concise. 1.16. What is the ratio of the Pupil-teacher ratio(headcount basis) in High income in 1971 to that in 2004?
Ensure brevity in your answer.  1.14. What is the ratio of the Pupil-teacher ratio(headcount basis) in Comoros in 1971 to that in 2004?
Your answer should be compact. 1.46. What is the ratio of the Pupil-teacher ratio(headcount basis) of Panama in 1971 to that in 2004?
Ensure brevity in your answer.  1.23. What is the ratio of the Pupil-teacher ratio(headcount basis) in East Asia (all income levels) in 1971 to that in 2013?
Your response must be concise. 1.33. What is the ratio of the Pupil-teacher ratio(headcount basis) in High income in 1971 to that in 2013?
Provide a succinct answer. 1.17. What is the ratio of the Pupil-teacher ratio(headcount basis) of Comoros in 1971 to that in 2013?
Provide a short and direct response. 2.32. What is the ratio of the Pupil-teacher ratio(headcount basis) in Panama in 1971 to that in 2013?
Make the answer very short. 1.25. What is the ratio of the Pupil-teacher ratio(headcount basis) in East Asia (all income levels) in 1973 to that in 1974?
Offer a very short reply. 1.03. What is the ratio of the Pupil-teacher ratio(headcount basis) in Comoros in 1973 to that in 1974?
Provide a succinct answer. 0.93. What is the ratio of the Pupil-teacher ratio(headcount basis) in Panama in 1973 to that in 1974?
Provide a short and direct response. 0.97. What is the ratio of the Pupil-teacher ratio(headcount basis) in East Asia (all income levels) in 1973 to that in 1981?
Offer a very short reply. 1.11. What is the ratio of the Pupil-teacher ratio(headcount basis) of High income in 1973 to that in 1981?
Provide a short and direct response. 1.02. What is the ratio of the Pupil-teacher ratio(headcount basis) of Comoros in 1973 to that in 1981?
Keep it short and to the point. 0.76. What is the ratio of the Pupil-teacher ratio(headcount basis) in Panama in 1973 to that in 1981?
Provide a short and direct response. 1.02. What is the ratio of the Pupil-teacher ratio(headcount basis) of East Asia (all income levels) in 1973 to that in 2002?
Offer a terse response. 1.13. What is the ratio of the Pupil-teacher ratio(headcount basis) in High income in 1973 to that in 2002?
Your answer should be very brief. 1.13. What is the ratio of the Pupil-teacher ratio(headcount basis) in Comoros in 1973 to that in 2002?
Provide a succinct answer. 1.78. What is the ratio of the Pupil-teacher ratio(headcount basis) in Panama in 1973 to that in 2002?
Keep it short and to the point. 1.28. What is the ratio of the Pupil-teacher ratio(headcount basis) in East Asia (all income levels) in 1973 to that in 2004?
Keep it short and to the point. 1.14. What is the ratio of the Pupil-teacher ratio(headcount basis) of High income in 1973 to that in 2004?
Offer a terse response. 1.15. What is the ratio of the Pupil-teacher ratio(headcount basis) of Comoros in 1973 to that in 2004?
Ensure brevity in your answer.  1.68. What is the ratio of the Pupil-teacher ratio(headcount basis) in Panama in 1973 to that in 2004?
Provide a short and direct response. 1.31. What is the ratio of the Pupil-teacher ratio(headcount basis) of East Asia (all income levels) in 1973 to that in 2013?
Provide a short and direct response. 1.32. What is the ratio of the Pupil-teacher ratio(headcount basis) of High income in 1973 to that in 2013?
Your response must be concise. 1.18. What is the ratio of the Pupil-teacher ratio(headcount basis) of Comoros in 1973 to that in 2013?
Your answer should be very brief. 2.67. What is the ratio of the Pupil-teacher ratio(headcount basis) of Panama in 1973 to that in 2013?
Make the answer very short. 1.33. What is the ratio of the Pupil-teacher ratio(headcount basis) in East Asia (all income levels) in 1974 to that in 1981?
Your response must be concise. 1.07. What is the ratio of the Pupil-teacher ratio(headcount basis) in High income in 1974 to that in 1981?
Keep it short and to the point. 1.02. What is the ratio of the Pupil-teacher ratio(headcount basis) in Comoros in 1974 to that in 1981?
Offer a terse response. 0.81. What is the ratio of the Pupil-teacher ratio(headcount basis) in Panama in 1974 to that in 1981?
Keep it short and to the point. 1.05. What is the ratio of the Pupil-teacher ratio(headcount basis) of East Asia (all income levels) in 1974 to that in 2002?
Give a very brief answer. 1.09. What is the ratio of the Pupil-teacher ratio(headcount basis) of High income in 1974 to that in 2002?
Provide a short and direct response. 1.13. What is the ratio of the Pupil-teacher ratio(headcount basis) in Comoros in 1974 to that in 2002?
Make the answer very short. 1.92. What is the ratio of the Pupil-teacher ratio(headcount basis) in Panama in 1974 to that in 2002?
Make the answer very short. 1.32. What is the ratio of the Pupil-teacher ratio(headcount basis) of East Asia (all income levels) in 1974 to that in 2004?
Offer a terse response. 1.11. What is the ratio of the Pupil-teacher ratio(headcount basis) in High income in 1974 to that in 2004?
Keep it short and to the point. 1.15. What is the ratio of the Pupil-teacher ratio(headcount basis) of Comoros in 1974 to that in 2004?
Make the answer very short. 1.81. What is the ratio of the Pupil-teacher ratio(headcount basis) of Panama in 1974 to that in 2004?
Your answer should be compact. 1.35. What is the ratio of the Pupil-teacher ratio(headcount basis) in East Asia (all income levels) in 1974 to that in 2013?
Offer a terse response. 1.28. What is the ratio of the Pupil-teacher ratio(headcount basis) in High income in 1974 to that in 2013?
Your answer should be compact. 1.18. What is the ratio of the Pupil-teacher ratio(headcount basis) of Comoros in 1974 to that in 2013?
Offer a very short reply. 2.87. What is the ratio of the Pupil-teacher ratio(headcount basis) of Panama in 1974 to that in 2013?
Your answer should be very brief. 1.37. What is the ratio of the Pupil-teacher ratio(headcount basis) in East Asia (all income levels) in 1981 to that in 2002?
Make the answer very short. 1.02. What is the ratio of the Pupil-teacher ratio(headcount basis) in High income in 1981 to that in 2002?
Your response must be concise. 1.11. What is the ratio of the Pupil-teacher ratio(headcount basis) in Comoros in 1981 to that in 2002?
Give a very brief answer. 2.36. What is the ratio of the Pupil-teacher ratio(headcount basis) of Panama in 1981 to that in 2002?
Keep it short and to the point. 1.26. What is the ratio of the Pupil-teacher ratio(headcount basis) in East Asia (all income levels) in 1981 to that in 2004?
Provide a short and direct response. 1.03. What is the ratio of the Pupil-teacher ratio(headcount basis) in High income in 1981 to that in 2004?
Keep it short and to the point. 1.13. What is the ratio of the Pupil-teacher ratio(headcount basis) in Comoros in 1981 to that in 2004?
Ensure brevity in your answer.  2.23. What is the ratio of the Pupil-teacher ratio(headcount basis) of Panama in 1981 to that in 2004?
Provide a succinct answer. 1.28. What is the ratio of the Pupil-teacher ratio(headcount basis) in East Asia (all income levels) in 1981 to that in 2013?
Your answer should be very brief. 1.19. What is the ratio of the Pupil-teacher ratio(headcount basis) in High income in 1981 to that in 2013?
Your answer should be compact. 1.16. What is the ratio of the Pupil-teacher ratio(headcount basis) of Comoros in 1981 to that in 2013?
Your answer should be very brief. 3.53. What is the ratio of the Pupil-teacher ratio(headcount basis) of Panama in 1981 to that in 2013?
Offer a very short reply. 1.3. What is the ratio of the Pupil-teacher ratio(headcount basis) in East Asia (all income levels) in 2002 to that in 2004?
Offer a terse response. 1.01. What is the ratio of the Pupil-teacher ratio(headcount basis) in High income in 2002 to that in 2004?
Give a very brief answer. 1.02. What is the ratio of the Pupil-teacher ratio(headcount basis) of Comoros in 2002 to that in 2004?
Your answer should be compact. 0.95. What is the ratio of the Pupil-teacher ratio(headcount basis) of Panama in 2002 to that in 2004?
Your answer should be very brief. 1.02. What is the ratio of the Pupil-teacher ratio(headcount basis) in East Asia (all income levels) in 2002 to that in 2013?
Offer a very short reply. 1.17. What is the ratio of the Pupil-teacher ratio(headcount basis) in High income in 2002 to that in 2013?
Ensure brevity in your answer.  1.04. What is the ratio of the Pupil-teacher ratio(headcount basis) in Comoros in 2002 to that in 2013?
Your answer should be very brief. 1.5. What is the ratio of the Pupil-teacher ratio(headcount basis) of Panama in 2002 to that in 2013?
Your response must be concise. 1.04. What is the ratio of the Pupil-teacher ratio(headcount basis) of East Asia (all income levels) in 2004 to that in 2013?
Give a very brief answer. 1.15. What is the ratio of the Pupil-teacher ratio(headcount basis) in High income in 2004 to that in 2013?
Make the answer very short. 1.03. What is the ratio of the Pupil-teacher ratio(headcount basis) of Comoros in 2004 to that in 2013?
Offer a terse response. 1.58. What is the ratio of the Pupil-teacher ratio(headcount basis) of Panama in 2004 to that in 2013?
Give a very brief answer. 1.02. What is the difference between the highest and the second highest Pupil-teacher ratio(headcount basis) in East Asia (all income levels)?
Provide a short and direct response. 0.23. What is the difference between the highest and the second highest Pupil-teacher ratio(headcount basis) of High income?
Provide a short and direct response. 0.04. What is the difference between the highest and the second highest Pupil-teacher ratio(headcount basis) of Comoros?
Offer a terse response. 5.75. What is the difference between the highest and the second highest Pupil-teacher ratio(headcount basis) in Panama?
Ensure brevity in your answer.  0.66. What is the difference between the highest and the lowest Pupil-teacher ratio(headcount basis) of East Asia (all income levels)?
Your answer should be very brief. 5.28. What is the difference between the highest and the lowest Pupil-teacher ratio(headcount basis) in High income?
Your answer should be very brief. 2.23. What is the difference between the highest and the lowest Pupil-teacher ratio(headcount basis) in Comoros?
Your answer should be compact. 22.02. What is the difference between the highest and the lowest Pupil-teacher ratio(headcount basis) of Panama?
Offer a terse response. 5.77. 